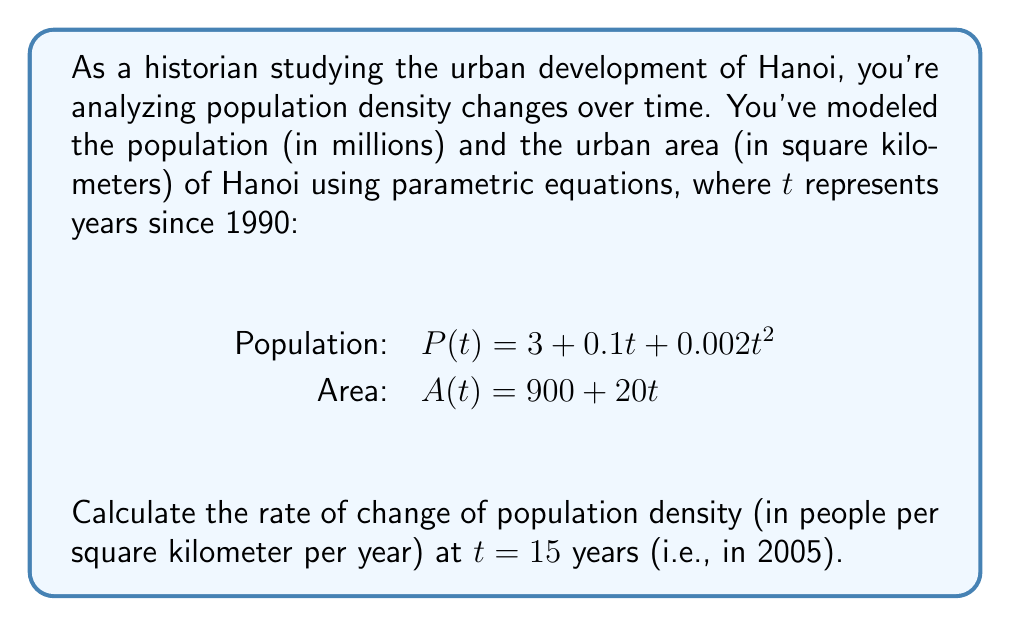Provide a solution to this math problem. To solve this problem, we'll follow these steps:

1) First, let's define population density D(t) as a function of t:
   $D(t) = \frac{P(t)}{A(t)} = \frac{3 + 0.1t + 0.002t^2}{900 + 20t}$

2) To find the rate of change of density, we need to differentiate D(t) with respect to t:
   $$\frac{dD}{dt} = \frac{d}{dt}\left(\frac{P(t)}{A(t)}\right)$$

3) Using the quotient rule, we get:
   $$\frac{dD}{dt} = \frac{A(t)\frac{dP}{dt} - P(t)\frac{dA}{dt}}{[A(t)]^2}$$

4) Calculate the derivatives:
   $\frac{dP}{dt} = 0.1 + 0.004t$
   $\frac{dA}{dt} = 20$

5) Substitute these into our equation:
   $$\frac{dD}{dt} = \frac{(900 + 20t)(0.1 + 0.004t) - (3 + 0.1t + 0.002t^2)(20)}{(900 + 20t)^2}$$

6) Now, we evaluate this at t = 15:
   $$\frac{dD}{dt}\bigg|_{t=15} = \frac{(900 + 20(15))(0.1 + 0.004(15)) - (3 + 0.1(15) + 0.002(15)^2)(20)}{(900 + 20(15))^2}$$

7) Simplify:
   $$\frac{dD}{dt}\bigg|_{t=15} = \frac{1200(0.16) - 5.45(20)}{1200^2} = \frac{192 - 109}{1440000} = \frac{83}{1440000}$$

8) This gives us approximately 0.0000576 million people per square kilometer per year.

9) Convert to people per square kilometer per year:
   0.0000576 * 1,000,000 ≈ 57.6
Answer: 57.6 people/km²/year 